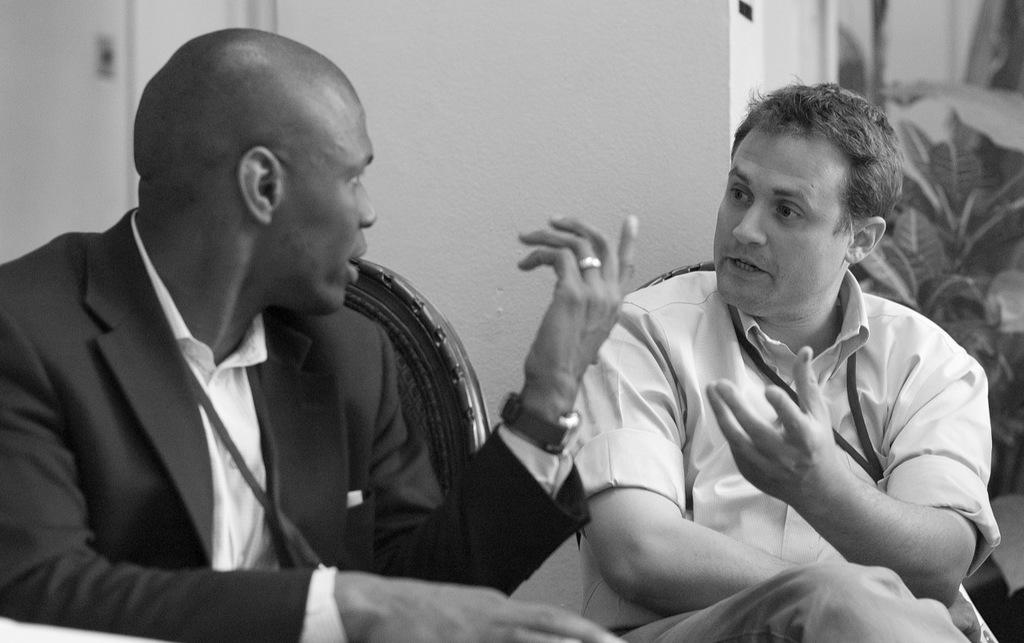How many people are present in the image? There are two persons sitting in the image. What can be seen in the background of the image? There are plants and a wall in the background of the image. What is the color scheme of the image? The image is in black and white. How many children are playing in the building shown in the image? There are no children or buildings present in the image; it features two persons sitting in a setting with plants and a wall in the background. 